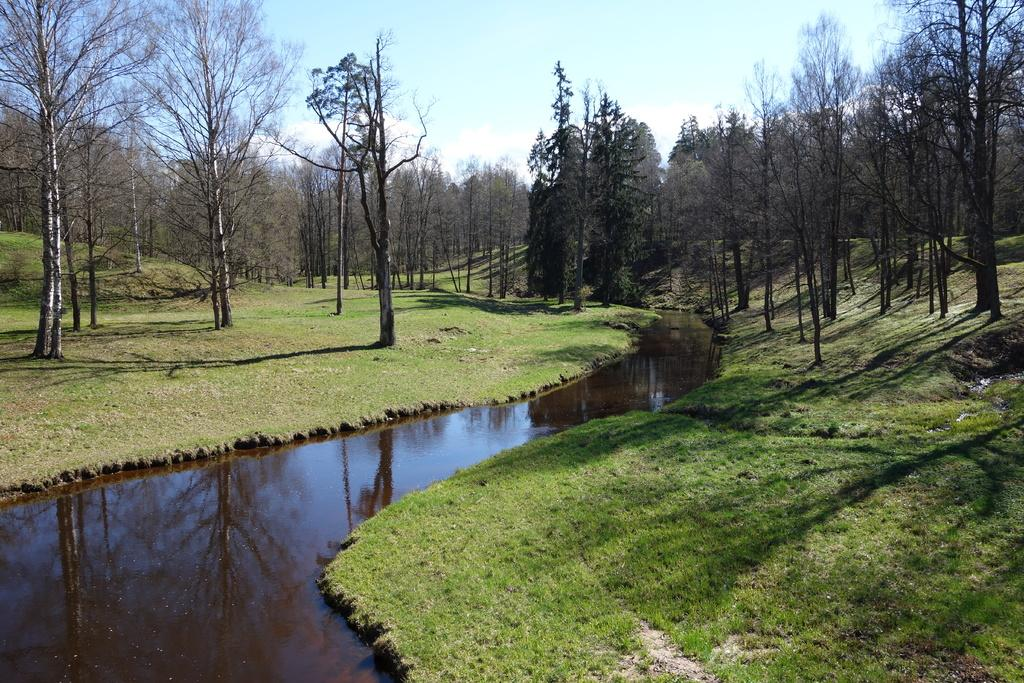What type of vegetation can be seen in the image? There are many trees in the image. What is visible at the bottom of the image? There is water and grass visible at the bottom of the image. What is visible at the top of the image? The sky is visible at the top of the image. What can be seen in the sky? Clouds are present in the sky. What book is the father reading in the image? There is no father or book present in the image. 